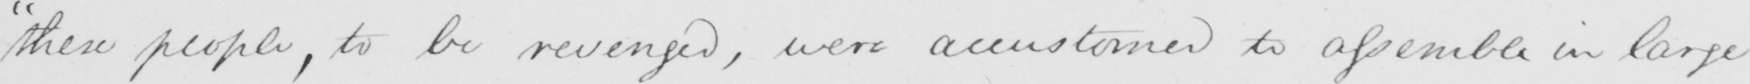Can you tell me what this handwritten text says? "these people, to be revenged, were accustomed to assemble in large 